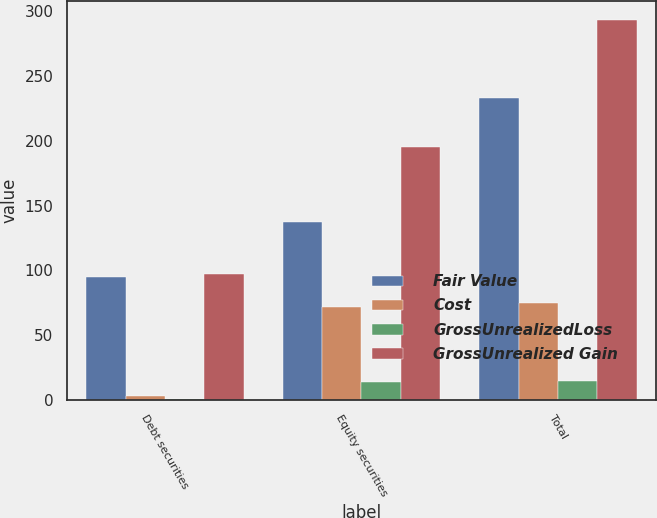Convert chart to OTSL. <chart><loc_0><loc_0><loc_500><loc_500><stacked_bar_chart><ecel><fcel>Debt securities<fcel>Equity securities<fcel>Total<nl><fcel>Fair Value<fcel>95<fcel>137<fcel>233<nl><fcel>Cost<fcel>3<fcel>72<fcel>75<nl><fcel>GrossUnrealizedLoss<fcel>1<fcel>14<fcel>15<nl><fcel>GrossUnrealized Gain<fcel>97<fcel>195<fcel>293<nl></chart> 